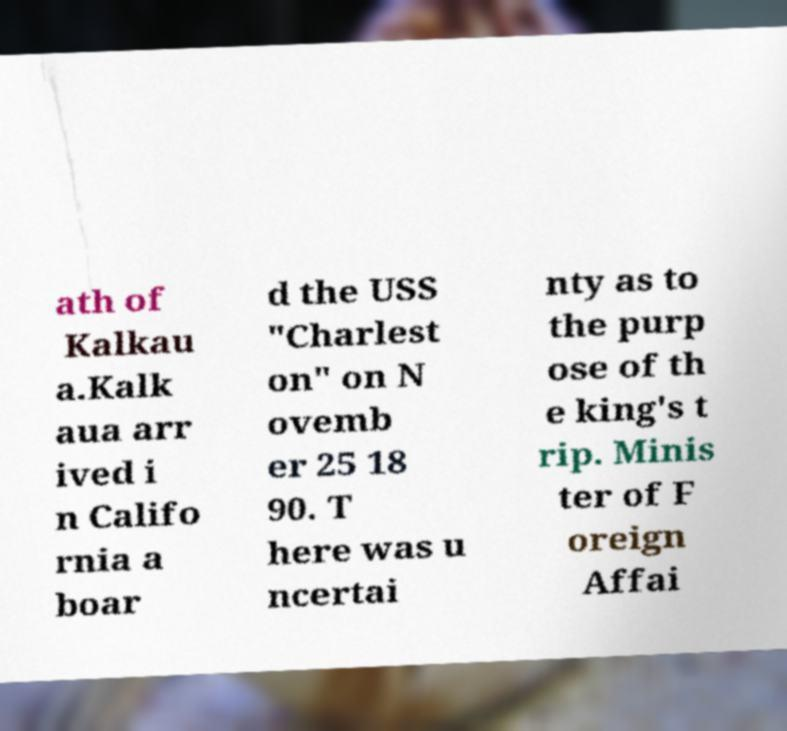For documentation purposes, I need the text within this image transcribed. Could you provide that? ath of Kalkau a.Kalk aua arr ived i n Califo rnia a boar d the USS "Charlest on" on N ovemb er 25 18 90. T here was u ncertai nty as to the purp ose of th e king's t rip. Minis ter of F oreign Affai 